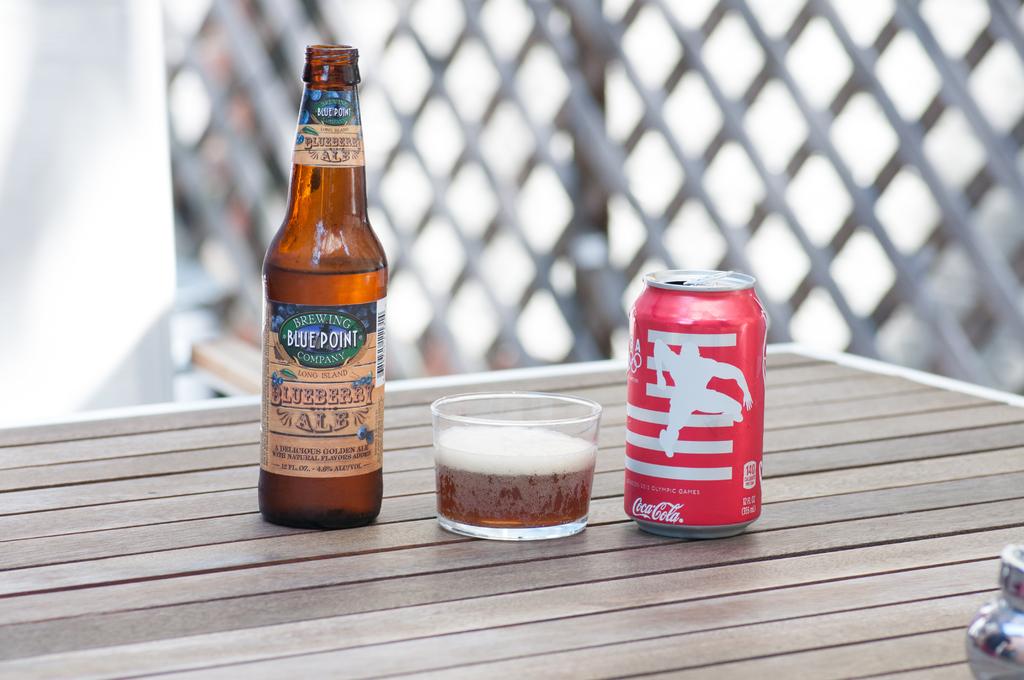What fruit is the ale on the left named after?
Provide a succinct answer. Blueberry. What brewing company made the beer?
Provide a succinct answer. Blue point. 